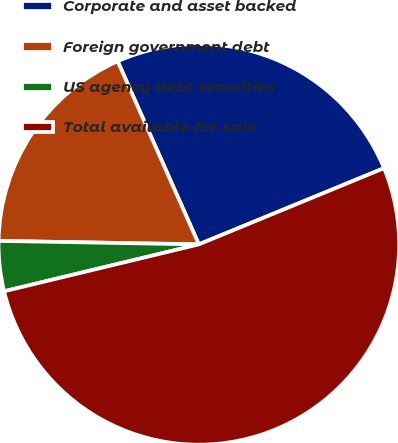Convert chart to OTSL. <chart><loc_0><loc_0><loc_500><loc_500><pie_chart><fcel>Corporate and asset backed<fcel>Foreign government debt<fcel>US agency debt securities<fcel>Total available-for-sale<nl><fcel>25.43%<fcel>18.08%<fcel>4.04%<fcel>52.45%<nl></chart> 